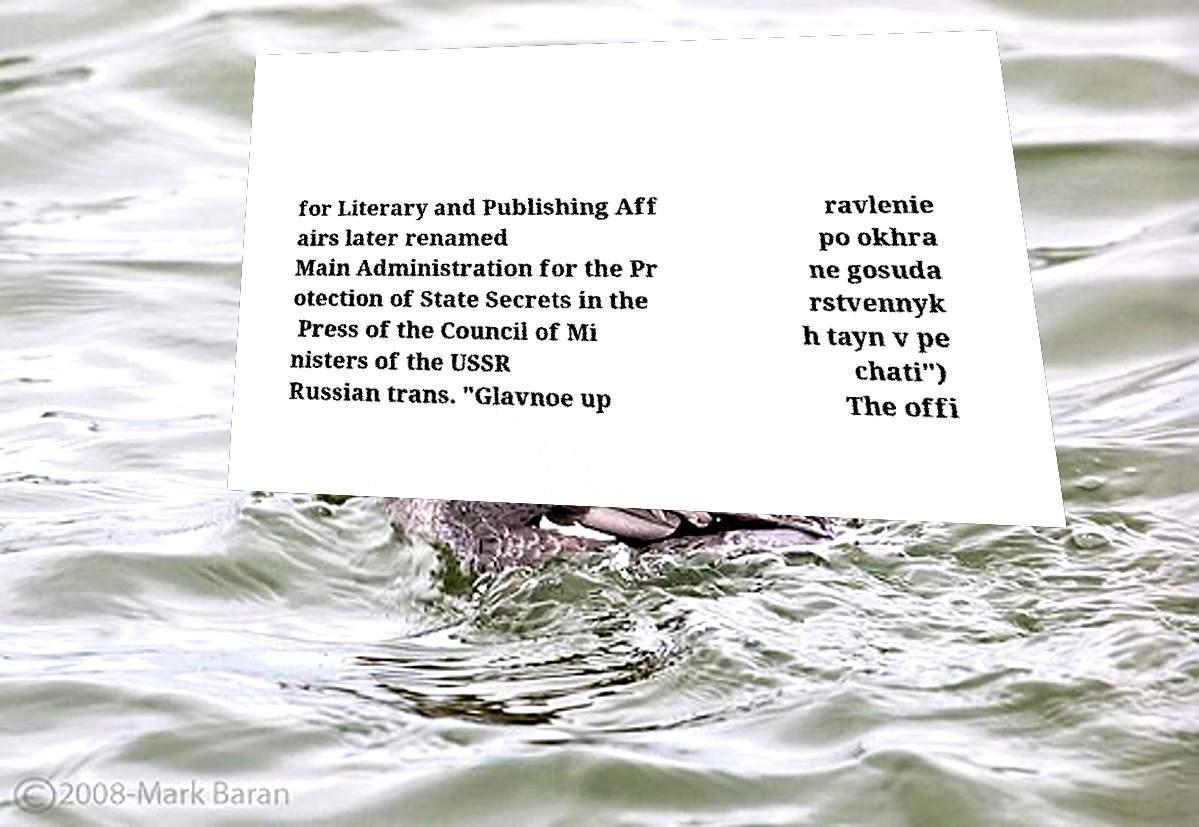There's text embedded in this image that I need extracted. Can you transcribe it verbatim? for Literary and Publishing Aff airs later renamed Main Administration for the Pr otection of State Secrets in the Press of the Council of Mi nisters of the USSR Russian trans. "Glavnoe up ravlenie po okhra ne gosuda rstvennyk h tayn v pe chati") The offi 